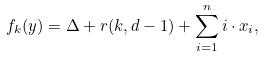<formula> <loc_0><loc_0><loc_500><loc_500>f _ { k } ( y ) = \Delta + r ( k , d - 1 ) + \sum _ { i = 1 } ^ { n } i \cdot x _ { i } ,</formula> 